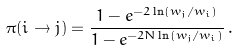<formula> <loc_0><loc_0><loc_500><loc_500>\pi ( i \rightarrow j ) = \frac { 1 - e ^ { - 2 \ln ( w _ { j } / w _ { i } ) } } { 1 - e ^ { - 2 N \ln ( w _ { j } / w _ { i } ) } } \, .</formula> 